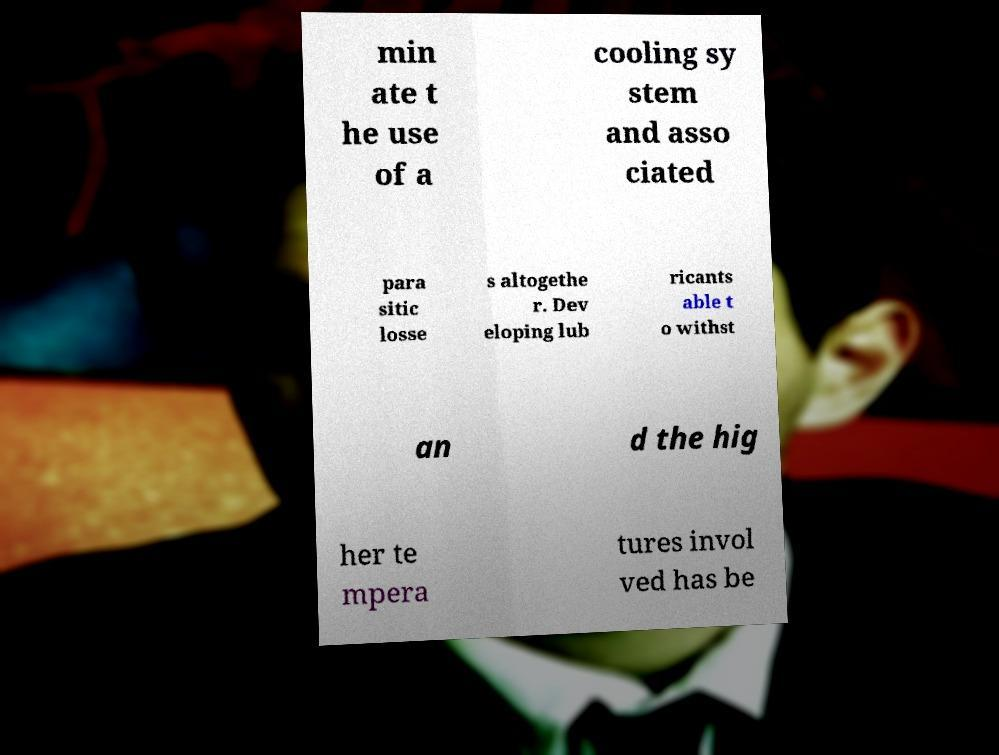Please read and relay the text visible in this image. What does it say? min ate t he use of a cooling sy stem and asso ciated para sitic losse s altogethe r. Dev eloping lub ricants able t o withst an d the hig her te mpera tures invol ved has be 